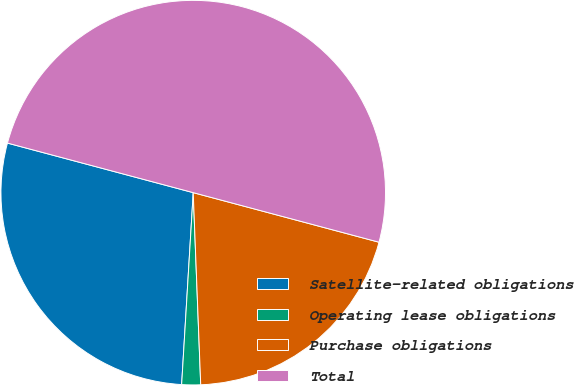<chart> <loc_0><loc_0><loc_500><loc_500><pie_chart><fcel>Satellite-related obligations<fcel>Operating lease obligations<fcel>Purchase obligations<fcel>Total<nl><fcel>28.19%<fcel>1.58%<fcel>20.23%<fcel>50.0%<nl></chart> 